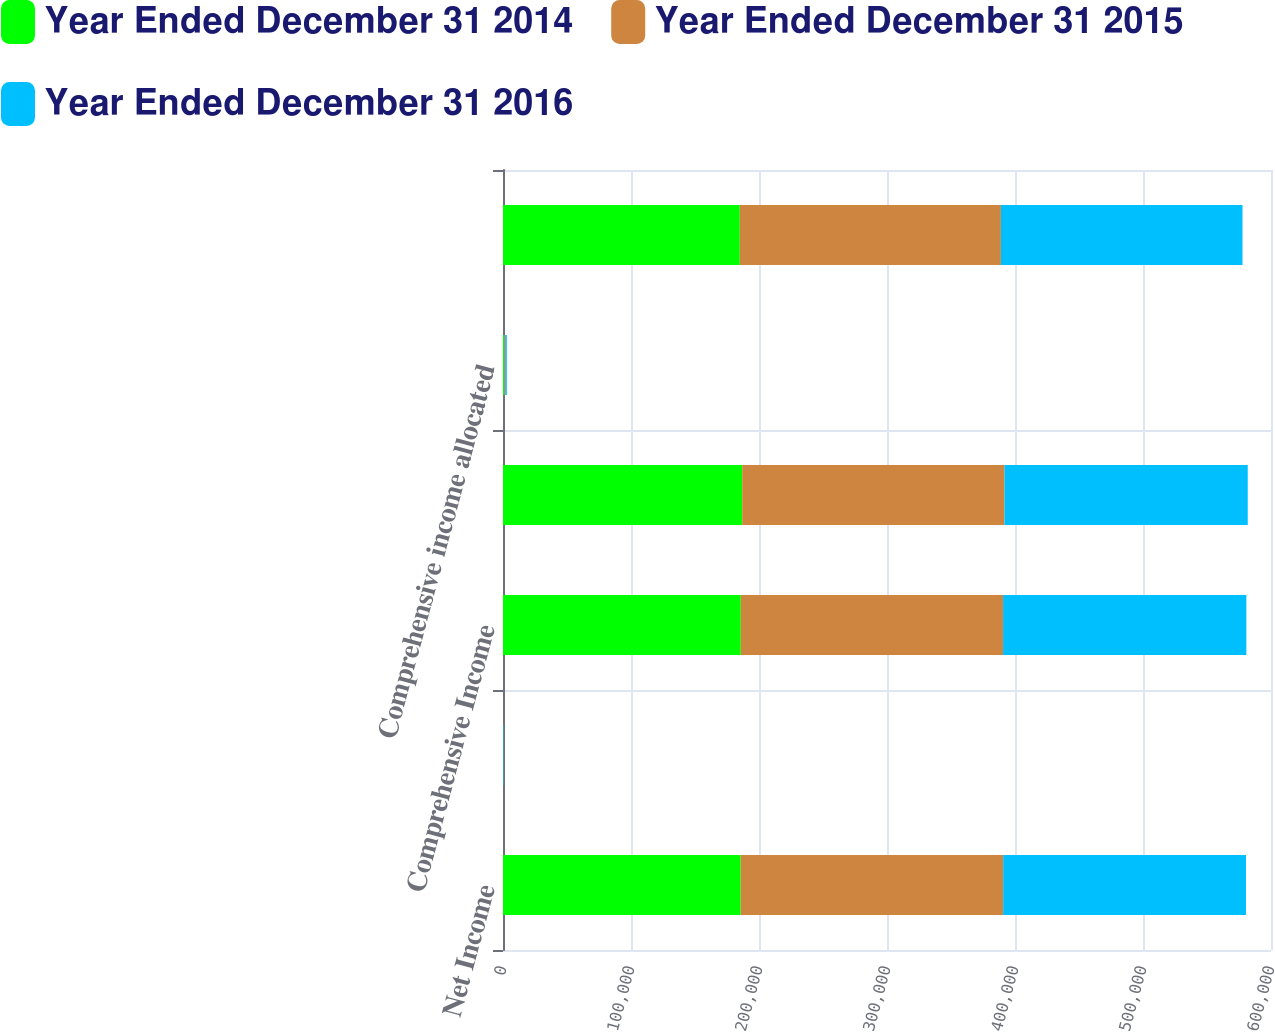Convert chart to OTSL. <chart><loc_0><loc_0><loc_500><loc_500><stacked_bar_chart><ecel><fcel>Net Income<fcel>Post retirement benefit<fcel>Comprehensive Income<fcel>Comprehensive Income Excluding<fcel>Comprehensive income allocated<fcel>Comprehensive Income Allocated<nl><fcel>Year Ended December 31 2014<fcel>185720<fcel>62<fcel>185782<fcel>186882<fcel>775<fcel>185007<nl><fcel>Year Ended December 31 2015<fcel>205023<fcel>135<fcel>204888<fcel>204888<fcel>898<fcel>203990<nl><fcel>Year Ended December 31 2016<fcel>189714<fcel>361<fcel>190075<fcel>190075<fcel>1322<fcel>188753<nl></chart> 